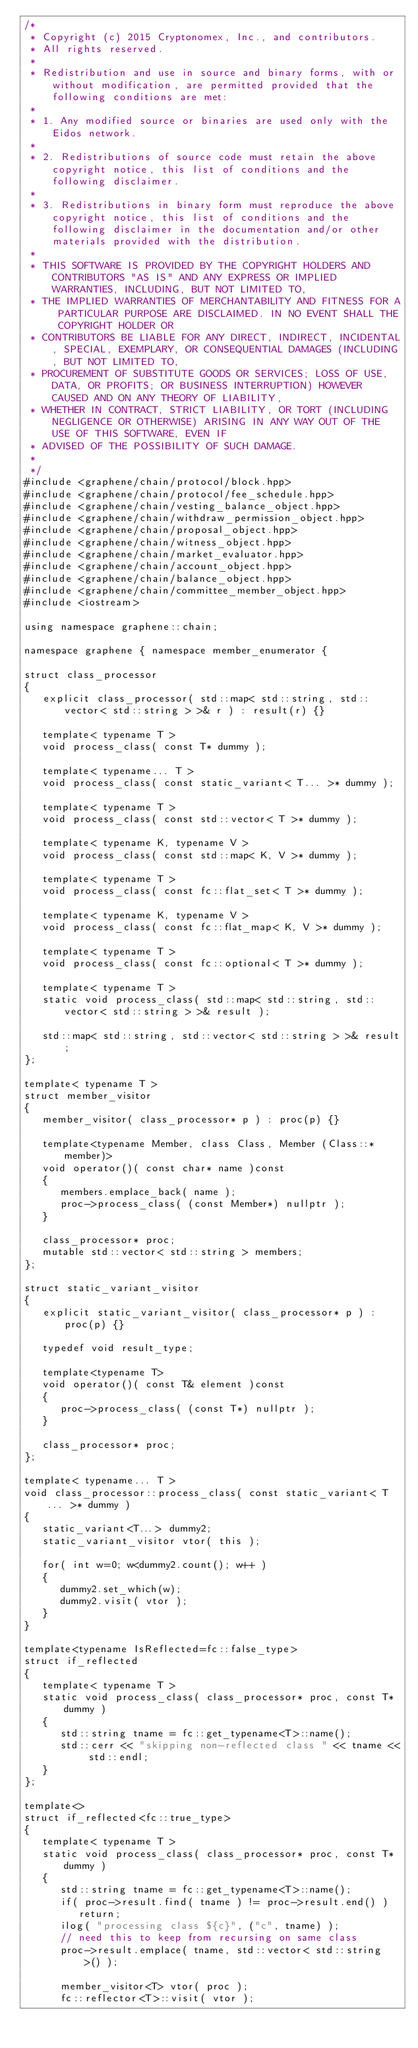Convert code to text. <code><loc_0><loc_0><loc_500><loc_500><_C++_>/*
 * Copyright (c) 2015 Cryptonomex, Inc., and contributors.
 * All rights reserved.
 *
 * Redistribution and use in source and binary forms, with or without modification, are permitted provided that the following conditions are met:
 *
 * 1. Any modified source or binaries are used only with the Eidos network.
 *
 * 2. Redistributions of source code must retain the above copyright notice, this list of conditions and the following disclaimer.
 *
 * 3. Redistributions in binary form must reproduce the above copyright notice, this list of conditions and the following disclaimer in the documentation and/or other materials provided with the distribution.
 *
 * THIS SOFTWARE IS PROVIDED BY THE COPYRIGHT HOLDERS AND CONTRIBUTORS "AS IS" AND ANY EXPRESS OR IMPLIED WARRANTIES, INCLUDING, BUT NOT LIMITED TO,
 * THE IMPLIED WARRANTIES OF MERCHANTABILITY AND FITNESS FOR A PARTICULAR PURPOSE ARE DISCLAIMED. IN NO EVENT SHALL THE COPYRIGHT HOLDER OR
 * CONTRIBUTORS BE LIABLE FOR ANY DIRECT, INDIRECT, INCIDENTAL, SPECIAL, EXEMPLARY, OR CONSEQUENTIAL DAMAGES (INCLUDING, BUT NOT LIMITED TO,
 * PROCUREMENT OF SUBSTITUTE GOODS OR SERVICES; LOSS OF USE, DATA, OR PROFITS; OR BUSINESS INTERRUPTION) HOWEVER CAUSED AND ON ANY THEORY OF LIABILITY,
 * WHETHER IN CONTRACT, STRICT LIABILITY, OR TORT (INCLUDING NEGLIGENCE OR OTHERWISE) ARISING IN ANY WAY OUT OF THE USE OF THIS SOFTWARE, EVEN IF
 * ADVISED OF THE POSSIBILITY OF SUCH DAMAGE.
 *
 */
#include <graphene/chain/protocol/block.hpp>
#include <graphene/chain/protocol/fee_schedule.hpp>
#include <graphene/chain/vesting_balance_object.hpp>
#include <graphene/chain/withdraw_permission_object.hpp>
#include <graphene/chain/proposal_object.hpp>
#include <graphene/chain/witness_object.hpp>
#include <graphene/chain/market_evaluator.hpp>
#include <graphene/chain/account_object.hpp>
#include <graphene/chain/balance_object.hpp>
#include <graphene/chain/committee_member_object.hpp>
#include <iostream>

using namespace graphene::chain;

namespace graphene { namespace member_enumerator {

struct class_processor
{
   explicit class_processor( std::map< std::string, std::vector< std::string > >& r ) : result(r) {}

   template< typename T >
   void process_class( const T* dummy );

   template< typename... T >
   void process_class( const static_variant< T... >* dummy );

   template< typename T >
   void process_class( const std::vector< T >* dummy );

   template< typename K, typename V >
   void process_class( const std::map< K, V >* dummy );

   template< typename T >
   void process_class( const fc::flat_set< T >* dummy );

   template< typename K, typename V >
   void process_class( const fc::flat_map< K, V >* dummy );

   template< typename T >
   void process_class( const fc::optional< T >* dummy );

   template< typename T >
   static void process_class( std::map< std::string, std::vector< std::string > >& result );

   std::map< std::string, std::vector< std::string > >& result;
};

template< typename T >
struct member_visitor
{
   member_visitor( class_processor* p ) : proc(p) {}

   template<typename Member, class Class, Member (Class::*member)>
   void operator()( const char* name )const
   {
      members.emplace_back( name );
      proc->process_class( (const Member*) nullptr );
   }

   class_processor* proc;
   mutable std::vector< std::string > members;
};

struct static_variant_visitor
{
   explicit static_variant_visitor( class_processor* p ) : proc(p) {}

   typedef void result_type;

   template<typename T>
   void operator()( const T& element )const
   {
      proc->process_class( (const T*) nullptr );
   }

   class_processor* proc;
};

template< typename... T >
void class_processor::process_class( const static_variant< T... >* dummy )
{
   static_variant<T...> dummy2;
   static_variant_visitor vtor( this );

   for( int w=0; w<dummy2.count(); w++ )
   {
      dummy2.set_which(w);
      dummy2.visit( vtor );
   }
}

template<typename IsReflected=fc::false_type>
struct if_reflected
{
   template< typename T >
   static void process_class( class_processor* proc, const T* dummy )
   {
      std::string tname = fc::get_typename<T>::name();
      std::cerr << "skipping non-reflected class " << tname << std::endl;
   }
};

template<>
struct if_reflected<fc::true_type>
{
   template< typename T >
   static void process_class( class_processor* proc, const T* dummy )
   {
      std::string tname = fc::get_typename<T>::name();
      if( proc->result.find( tname ) != proc->result.end() )
         return;
      ilog( "processing class ${c}", ("c", tname) );
      // need this to keep from recursing on same class
      proc->result.emplace( tname, std::vector< std::string >() );

      member_visitor<T> vtor( proc );
      fc::reflector<T>::visit( vtor );</code> 